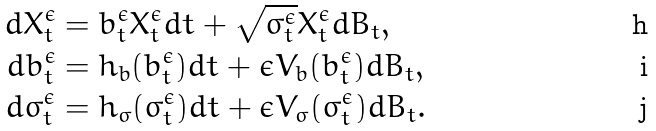Convert formula to latex. <formula><loc_0><loc_0><loc_500><loc_500>d X _ { t } ^ { \epsilon } & = b ^ { \epsilon } _ { t } X _ { t } ^ { \epsilon } d t + \sqrt { \sigma ^ { \epsilon } _ { t } } X _ { t } ^ { \epsilon } d B _ { t } , \\ d b ^ { \epsilon } _ { t } & = h _ { b } ( b ^ { \epsilon } _ { t } ) d t + \epsilon V _ { b } ( b ^ { \epsilon } _ { t } ) d B _ { t } , \\ d \sigma ^ { \epsilon } _ { t } & = h _ { \sigma } ( \sigma ^ { \epsilon } _ { t } ) d t + \epsilon V _ { \sigma } ( \sigma ^ { \epsilon } _ { t } ) d B _ { t } .</formula> 